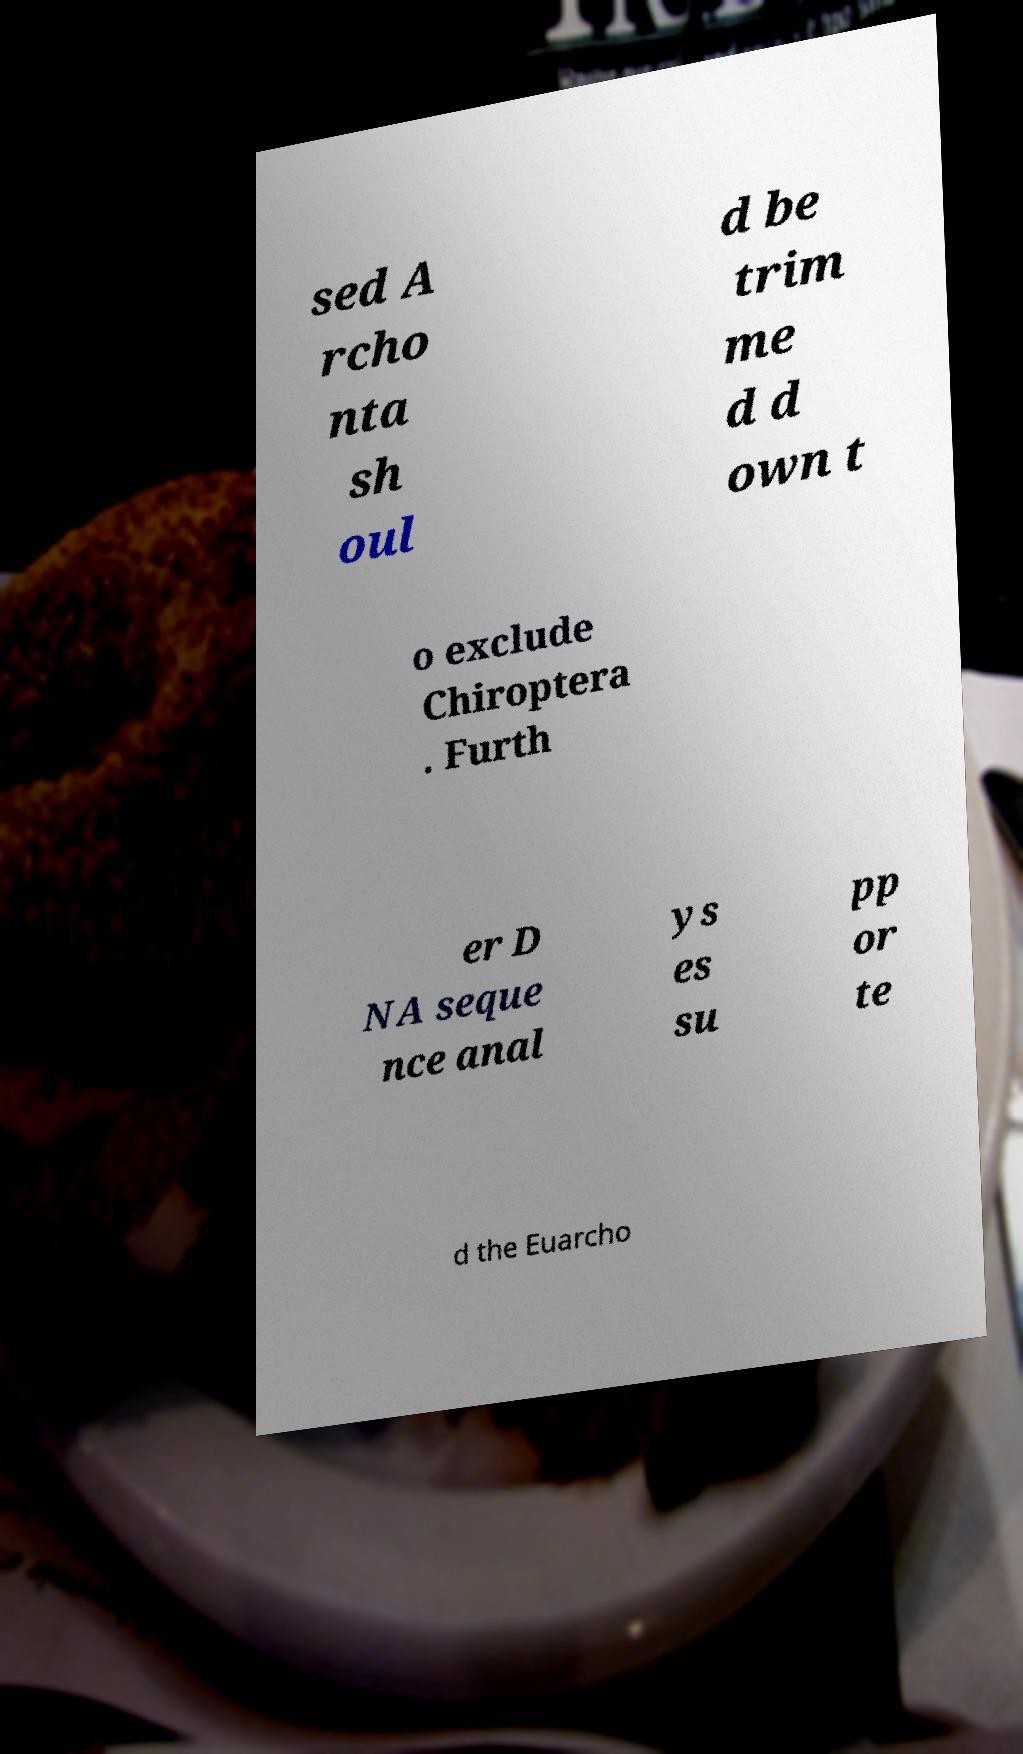For documentation purposes, I need the text within this image transcribed. Could you provide that? sed A rcho nta sh oul d be trim me d d own t o exclude Chiroptera . Furth er D NA seque nce anal ys es su pp or te d the Euarcho 